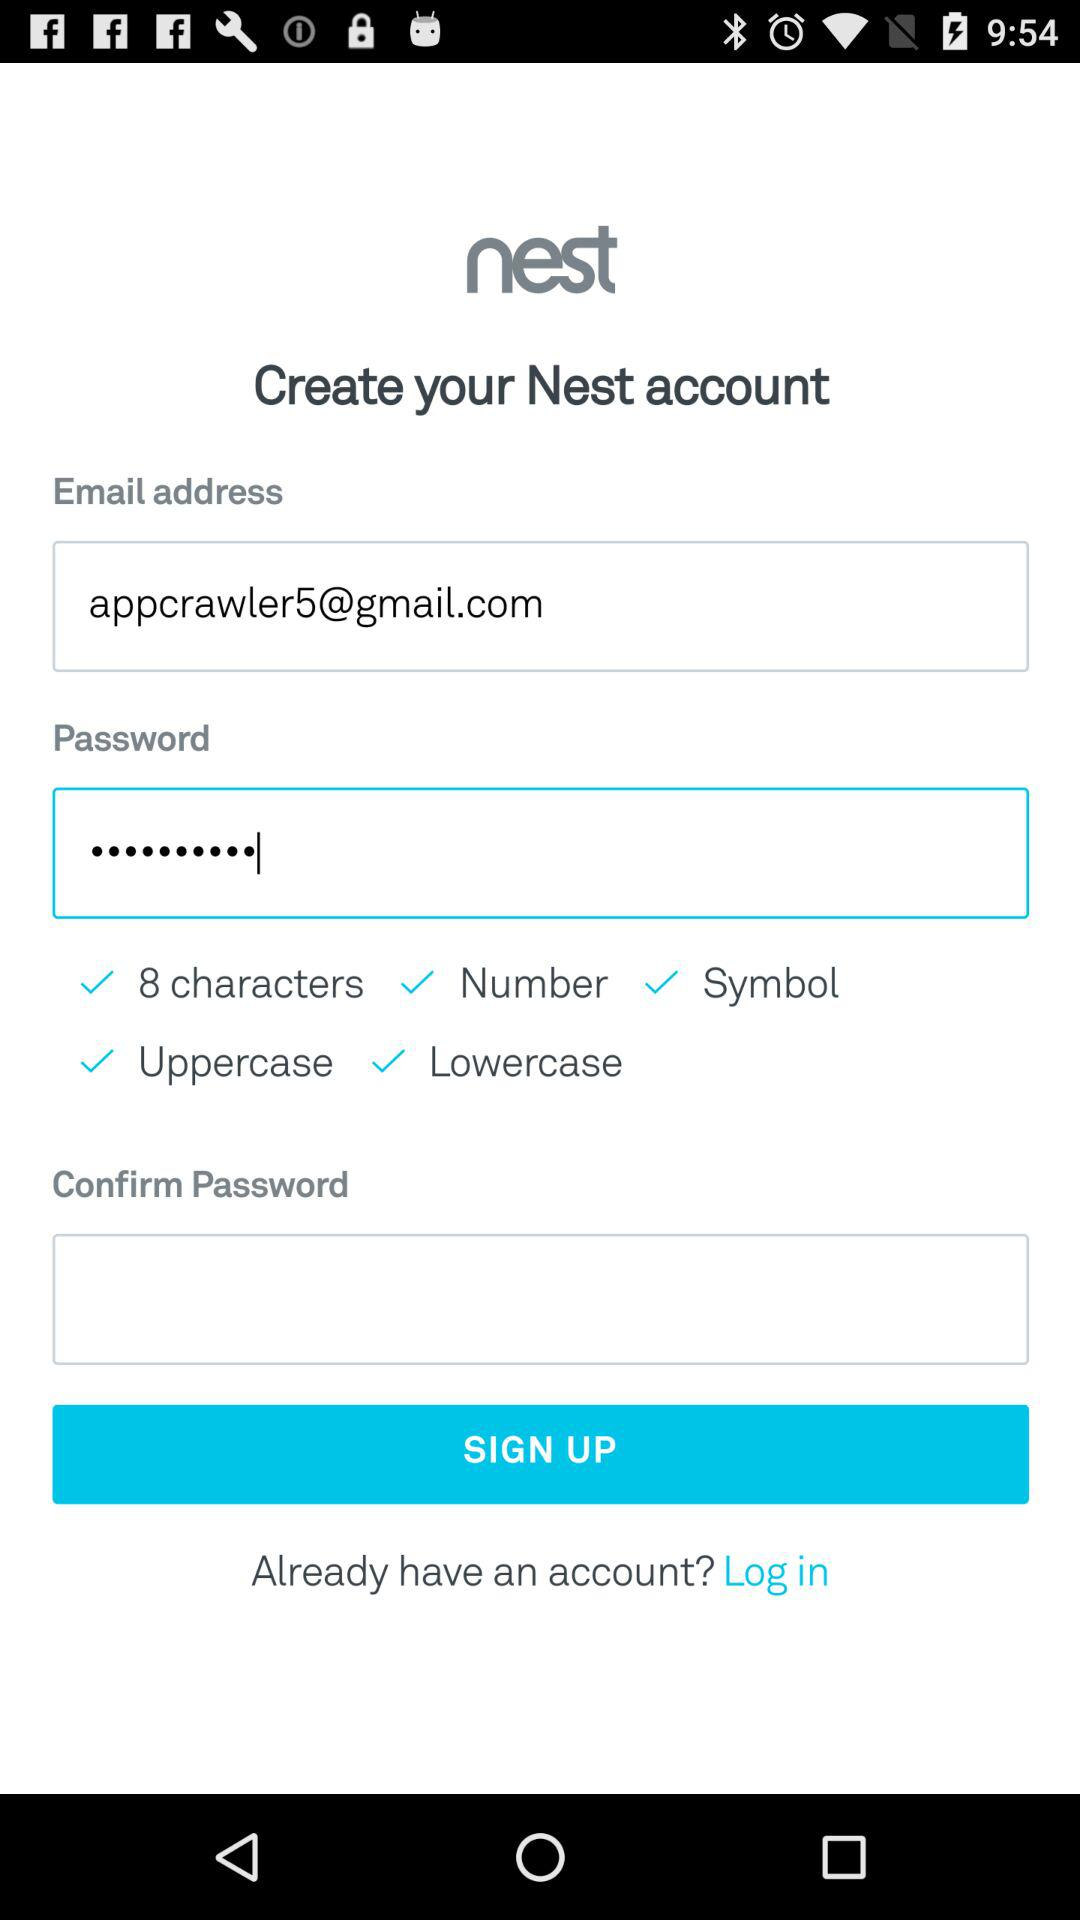What is the name of the application? The name of the application is "nest". 